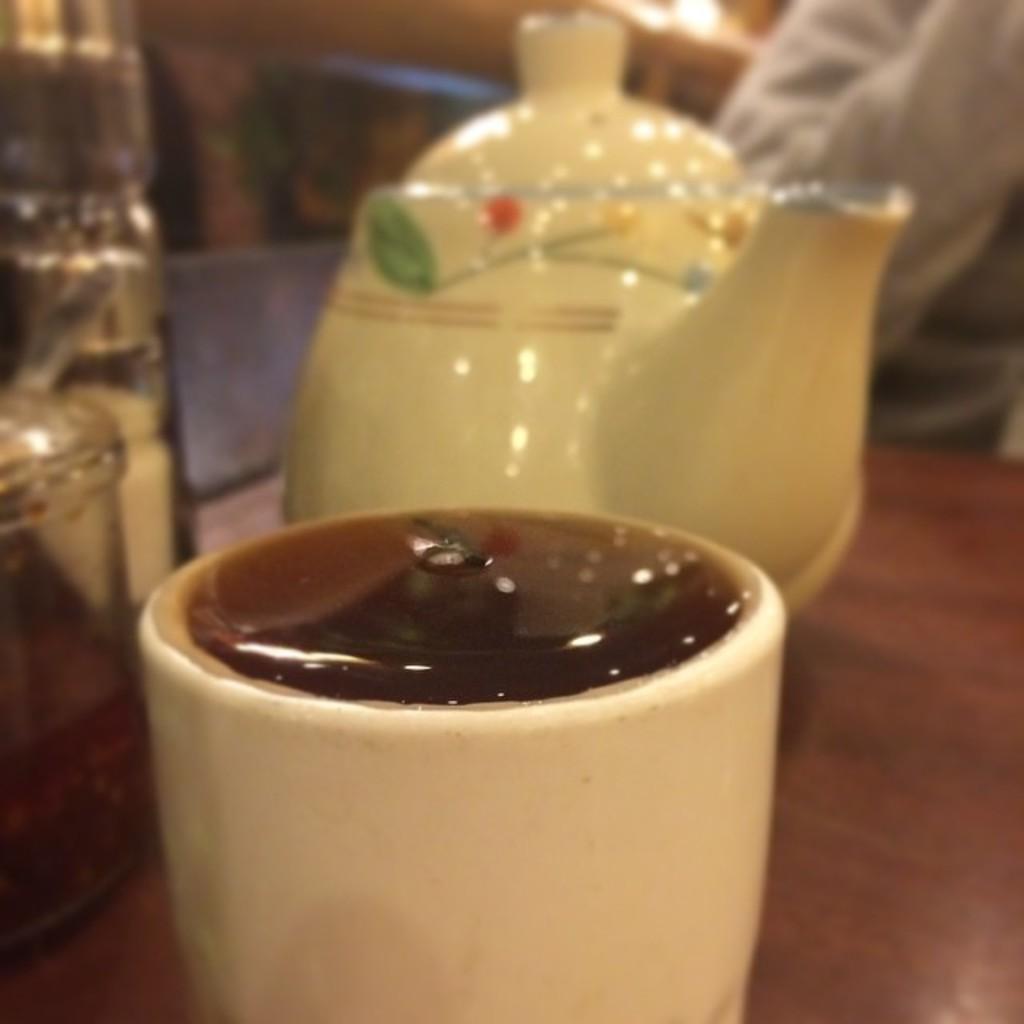Describe this image in one or two sentences. In this image there is a kettle, cup and few objects are on the table. Right side there is a person behind the table. 